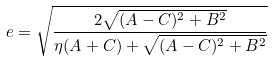Convert formula to latex. <formula><loc_0><loc_0><loc_500><loc_500>e = { \sqrt { \frac { 2 { \sqrt { ( A - C ) ^ { 2 } + B ^ { 2 } } } } { \eta ( A + C ) + { \sqrt { ( A - C ) ^ { 2 } + B ^ { 2 } } } } } }</formula> 